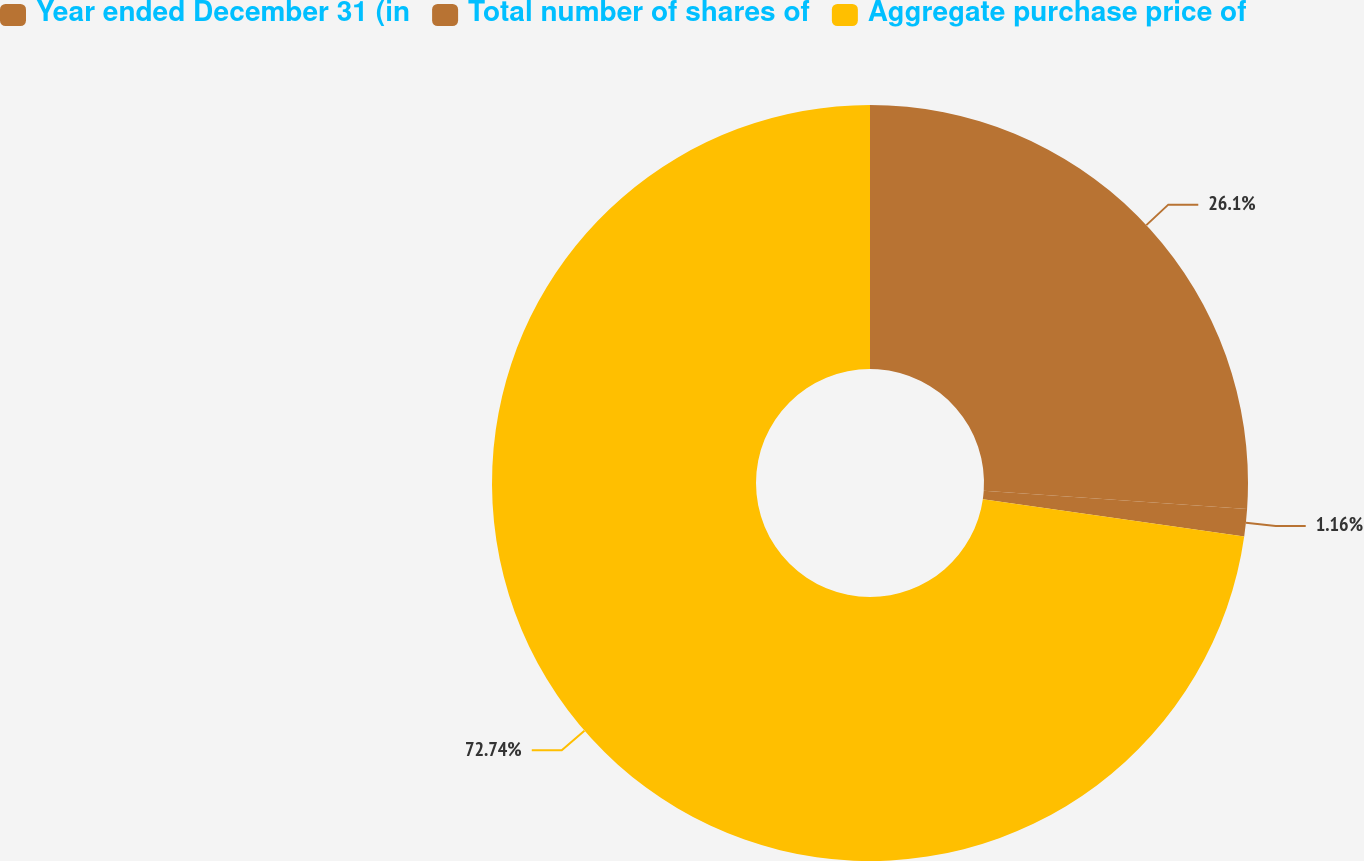Convert chart. <chart><loc_0><loc_0><loc_500><loc_500><pie_chart><fcel>Year ended December 31 (in<fcel>Total number of shares of<fcel>Aggregate purchase price of<nl><fcel>26.1%<fcel>1.16%<fcel>72.74%<nl></chart> 